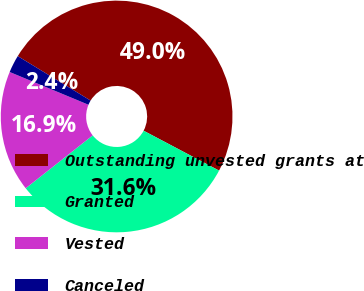Convert chart to OTSL. <chart><loc_0><loc_0><loc_500><loc_500><pie_chart><fcel>Outstanding unvested grants at<fcel>Granted<fcel>Vested<fcel>Canceled<nl><fcel>49.02%<fcel>31.63%<fcel>16.91%<fcel>2.45%<nl></chart> 